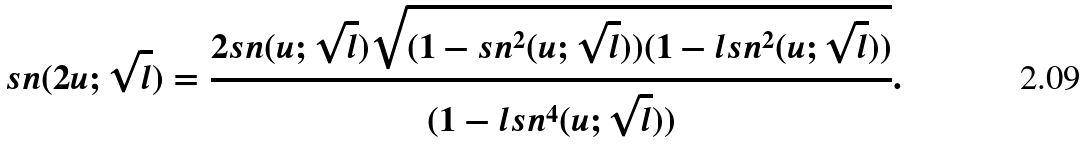<formula> <loc_0><loc_0><loc_500><loc_500>s n ( 2 u ; \sqrt { l } ) = \frac { 2 s n ( u ; \sqrt { l } ) \sqrt { ( 1 - s n ^ { 2 } ( u ; \sqrt { l } ) ) ( 1 - l s n ^ { 2 } ( u ; \sqrt { l } ) ) } } { ( 1 - l s n ^ { 4 } ( u ; \sqrt { l } ) ) } .</formula> 